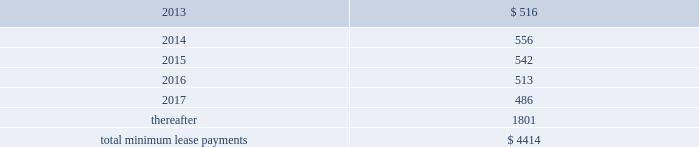Other off-balance sheet commitments lease commitments the company leases various equipment and facilities , including retail space , under noncancelable operating lease arrangements .
The company does not currently utilize any other off-balance sheet financing arrangements .
The major facility leases are typically for terms not exceeding 10 years and generally provide renewal options for terms not exceeding five additional years .
Leases for retail space are for terms ranging from five to 20 years , the majority of which are for 10 years , and often contain multi-year renewal options .
As of september 29 , 2012 , the company 2019s total future minimum lease payments under noncancelable operating leases were $ 4.4 billion , of which $ 3.1 billion related to leases for retail space .
Rent expense under all operating leases , including both cancelable and noncancelable leases , was $ 488 million , $ 338 million and $ 271 million in 2012 , 2011 and 2010 , respectively .
Future minimum lease payments under noncancelable operating leases having remaining terms in excess of one year as of september 29 , 2012 , are as follows ( in millions ) : .
Other commitments as of september 29 , 2012 , the company had outstanding off-balance sheet third-party manufacturing commitments and component purchase commitments of $ 21.1 billion .
In addition to the off-balance sheet commitments mentioned above , the company had outstanding obligations of $ 988 million as of september 29 , 2012 , which were comprised mainly of commitments to acquire capital assets , including product tooling and manufacturing process equipment , and commitments related to advertising , research and development , internet and telecommunications services and other obligations .
Contingencies the company is subject to various legal proceedings and claims that have arisen in the ordinary course of business and have not been fully adjudicated , certain of which are discussed in part i , item 3 of this form 10-k under the heading 201clegal proceedings 201d and in part i , item 1a of this form 10-k under the heading 201crisk factors . 201d in the opinion of management , there was not at least a reasonable possibility the company may have incurred a material loss , or a material loss in excess of a recorded accrual , with respect to loss contingencies .
However , the outcome of litigation is inherently uncertain .
Therefore , although management considers the likelihood of such an outcome to be remote , if one or more of these legal matters were resolved against the company in a reporting period for amounts in excess of management 2019s expectations , the company 2019s consolidated financial statements for that reporting period could be materially adversely affected .
Apple inc .
Vs samsung electronics co. , ltd , et al .
On august 24 , 2012 , a jury returned a verdict awarding the company $ 1.05 billion in its lawsuit against samsung electronics and affiliated parties in the united states district court , northern district of california , san jose division .
Because the award is subject to entry of final judgment and may be subject to appeal , the company has not recognized the award in its consolidated financial statements for the year ended september 29 , 2012. .
What was the percentage change in rent expense under operating leases from 2010 to 2011? 
Computations: ((338 - 271) / 271)
Answer: 0.24723. Other off-balance sheet commitments lease commitments the company leases various equipment and facilities , including retail space , under noncancelable operating lease arrangements .
The company does not currently utilize any other off-balance sheet financing arrangements .
The major facility leases are typically for terms not exceeding 10 years and generally provide renewal options for terms not exceeding five additional years .
Leases for retail space are for terms ranging from five to 20 years , the majority of which are for 10 years , and often contain multi-year renewal options .
As of september 29 , 2012 , the company 2019s total future minimum lease payments under noncancelable operating leases were $ 4.4 billion , of which $ 3.1 billion related to leases for retail space .
Rent expense under all operating leases , including both cancelable and noncancelable leases , was $ 488 million , $ 338 million and $ 271 million in 2012 , 2011 and 2010 , respectively .
Future minimum lease payments under noncancelable operating leases having remaining terms in excess of one year as of september 29 , 2012 , are as follows ( in millions ) : .
Other commitments as of september 29 , 2012 , the company had outstanding off-balance sheet third-party manufacturing commitments and component purchase commitments of $ 21.1 billion .
In addition to the off-balance sheet commitments mentioned above , the company had outstanding obligations of $ 988 million as of september 29 , 2012 , which were comprised mainly of commitments to acquire capital assets , including product tooling and manufacturing process equipment , and commitments related to advertising , research and development , internet and telecommunications services and other obligations .
Contingencies the company is subject to various legal proceedings and claims that have arisen in the ordinary course of business and have not been fully adjudicated , certain of which are discussed in part i , item 3 of this form 10-k under the heading 201clegal proceedings 201d and in part i , item 1a of this form 10-k under the heading 201crisk factors . 201d in the opinion of management , there was not at least a reasonable possibility the company may have incurred a material loss , or a material loss in excess of a recorded accrual , with respect to loss contingencies .
However , the outcome of litigation is inherently uncertain .
Therefore , although management considers the likelihood of such an outcome to be remote , if one or more of these legal matters were resolved against the company in a reporting period for amounts in excess of management 2019s expectations , the company 2019s consolidated financial statements for that reporting period could be materially adversely affected .
Apple inc .
Vs samsung electronics co. , ltd , et al .
On august 24 , 2012 , a jury returned a verdict awarding the company $ 1.05 billion in its lawsuit against samsung electronics and affiliated parties in the united states district court , northern district of california , san jose division .
Because the award is subject to entry of final judgment and may be subject to appeal , the company has not recognized the award in its consolidated financial statements for the year ended september 29 , 2012. .
What percentage of total minimum lease payments are due in 2016? 
Computations: (513 / 4414)
Answer: 0.11622. Other off-balance sheet commitments lease commitments the company leases various equipment and facilities , including retail space , under noncancelable operating lease arrangements .
The company does not currently utilize any other off-balance sheet financing arrangements .
The major facility leases are typically for terms not exceeding 10 years and generally provide renewal options for terms not exceeding five additional years .
Leases for retail space are for terms ranging from five to 20 years , the majority of which are for 10 years , and often contain multi-year renewal options .
As of september 29 , 2012 , the company 2019s total future minimum lease payments under noncancelable operating leases were $ 4.4 billion , of which $ 3.1 billion related to leases for retail space .
Rent expense under all operating leases , including both cancelable and noncancelable leases , was $ 488 million , $ 338 million and $ 271 million in 2012 , 2011 and 2010 , respectively .
Future minimum lease payments under noncancelable operating leases having remaining terms in excess of one year as of september 29 , 2012 , are as follows ( in millions ) : .
Other commitments as of september 29 , 2012 , the company had outstanding off-balance sheet third-party manufacturing commitments and component purchase commitments of $ 21.1 billion .
In addition to the off-balance sheet commitments mentioned above , the company had outstanding obligations of $ 988 million as of september 29 , 2012 , which were comprised mainly of commitments to acquire capital assets , including product tooling and manufacturing process equipment , and commitments related to advertising , research and development , internet and telecommunications services and other obligations .
Contingencies the company is subject to various legal proceedings and claims that have arisen in the ordinary course of business and have not been fully adjudicated , certain of which are discussed in part i , item 3 of this form 10-k under the heading 201clegal proceedings 201d and in part i , item 1a of this form 10-k under the heading 201crisk factors . 201d in the opinion of management , there was not at least a reasonable possibility the company may have incurred a material loss , or a material loss in excess of a recorded accrual , with respect to loss contingencies .
However , the outcome of litigation is inherently uncertain .
Therefore , although management considers the likelihood of such an outcome to be remote , if one or more of these legal matters were resolved against the company in a reporting period for amounts in excess of management 2019s expectations , the company 2019s consolidated financial statements for that reporting period could be materially adversely affected .
Apple inc .
Vs samsung electronics co. , ltd , et al .
On august 24 , 2012 , a jury returned a verdict awarding the company $ 1.05 billion in its lawsuit against samsung electronics and affiliated parties in the united states district court , northern district of california , san jose division .
Because the award is subject to entry of final judgment and may be subject to appeal , the company has not recognized the award in its consolidated financial statements for the year ended september 29 , 2012. .
What was the increase in rent expense under all operating leases , including both cancelable and noncancelable leases between 2012 and 2011 , in millions? 
Computations: (488 - 338)
Answer: 150.0. 